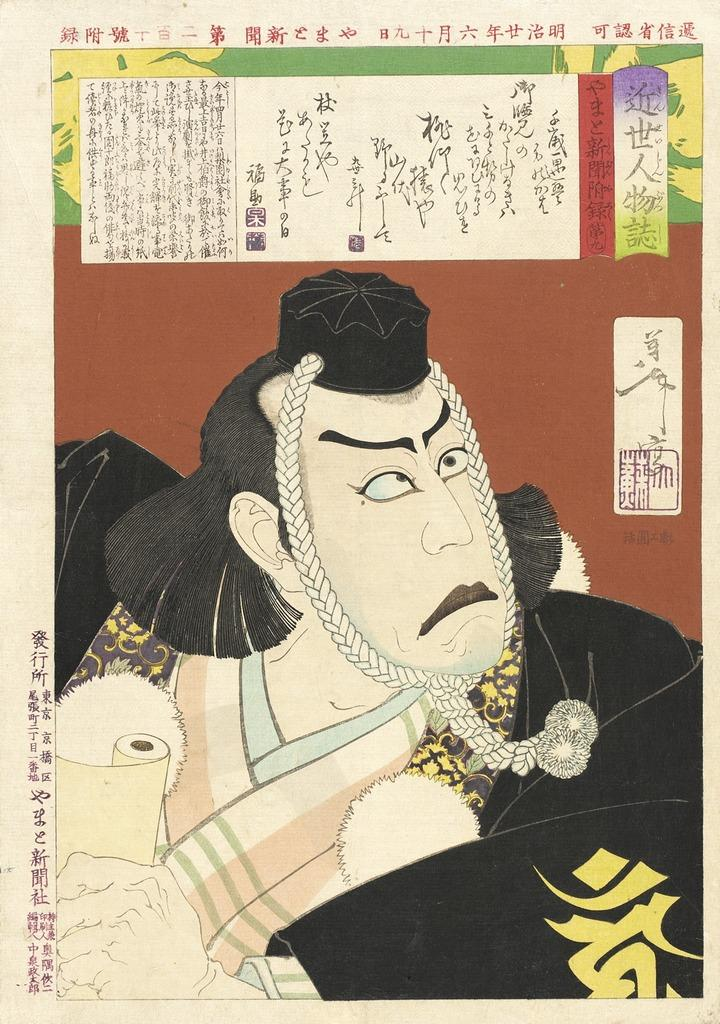What type of image is featured in the newspaper? The image contains a cartoon photograph. Can you describe the format of the image? The cartoon photograph is published in a newspaper. What type of mint is shown growing next to the cartoon photograph in the newspaper? There is no mint present in the image; it only contains a cartoon photograph published in a newspaper. 